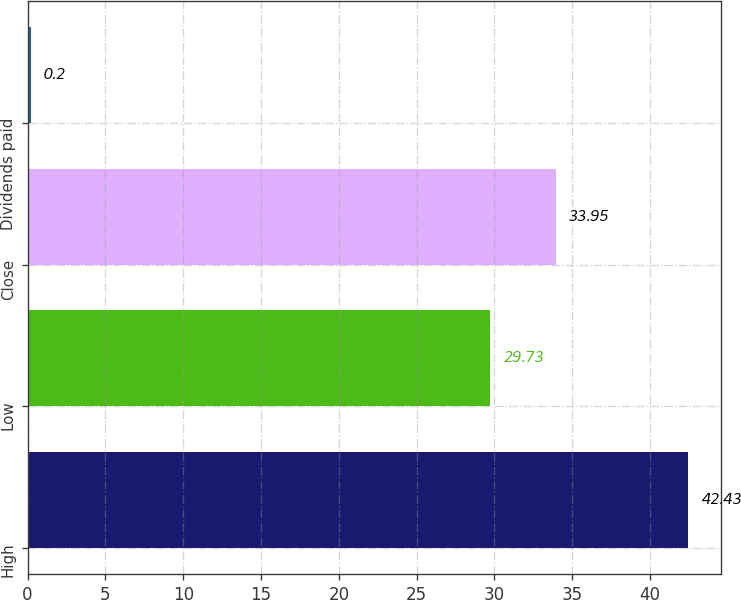<chart> <loc_0><loc_0><loc_500><loc_500><bar_chart><fcel>High<fcel>Low<fcel>Close<fcel>Dividends paid<nl><fcel>42.43<fcel>29.73<fcel>33.95<fcel>0.2<nl></chart> 